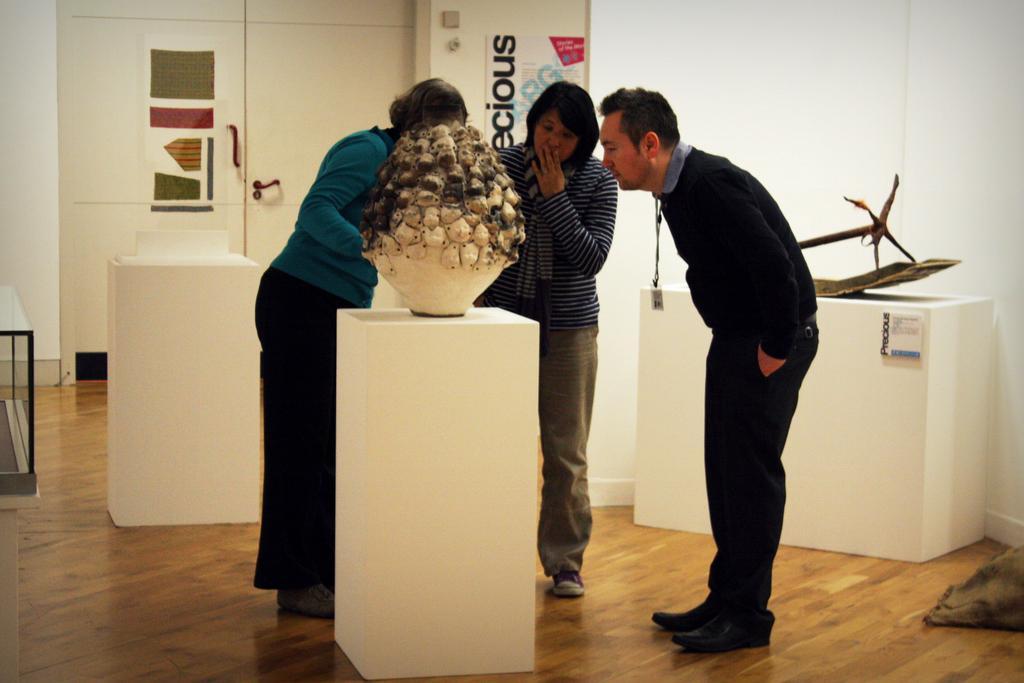Please provide a concise description of this image. In this image we can see three people standing. There is some object on the white color surface. At the bottom of the image there is wooden flooring. In the background of the image there is wall. There are posters on the wall. There is a door. To the right side of the image there is some object on the white color surface. 